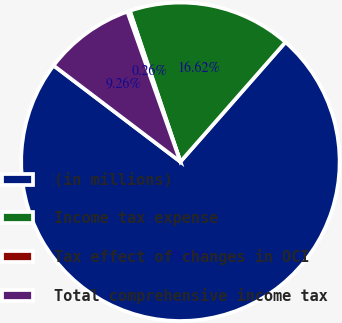Convert chart to OTSL. <chart><loc_0><loc_0><loc_500><loc_500><pie_chart><fcel>(in millions)<fcel>Income tax expense<fcel>Tax effect of changes in OCI<fcel>Total comprehensive income tax<nl><fcel>73.86%<fcel>16.62%<fcel>0.26%<fcel>9.26%<nl></chart> 